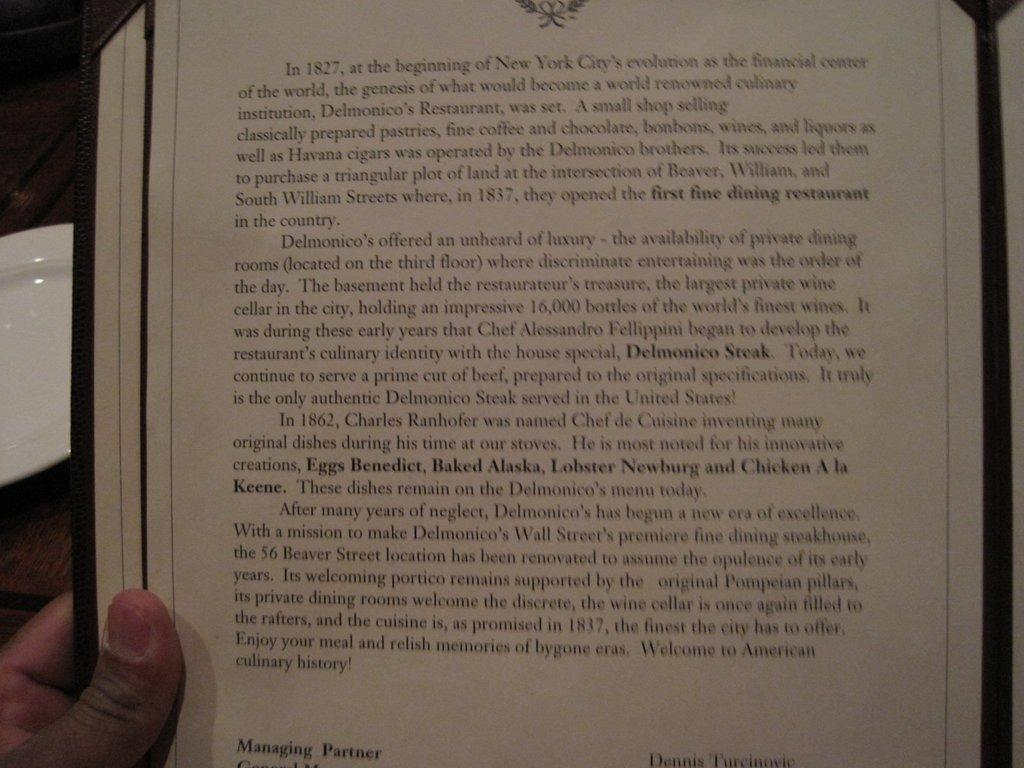Provide a one-sentence caption for the provided image. An excerpt from a menu at Delmonico's Restaurant tells the history and background about the place. 